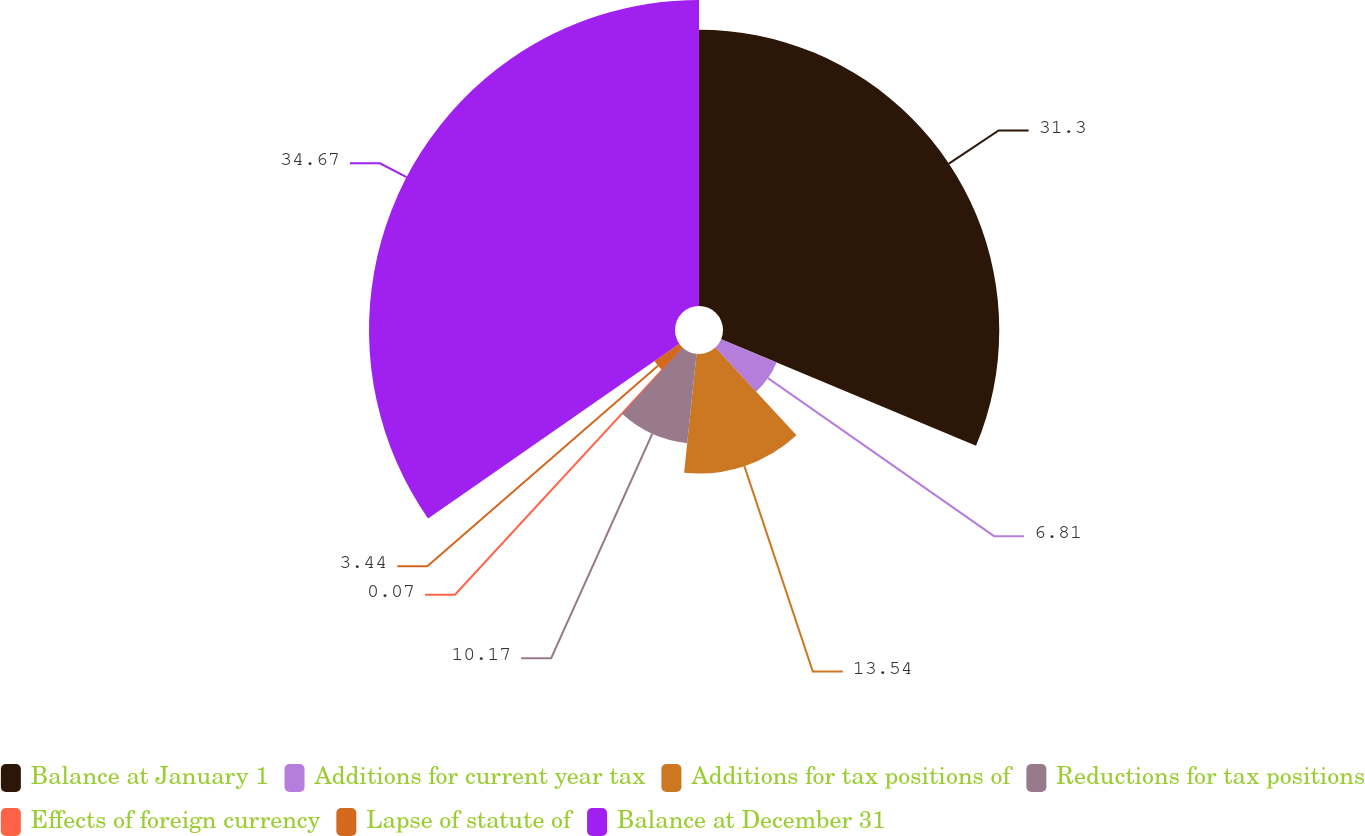Convert chart to OTSL. <chart><loc_0><loc_0><loc_500><loc_500><pie_chart><fcel>Balance at January 1<fcel>Additions for current year tax<fcel>Additions for tax positions of<fcel>Reductions for tax positions<fcel>Effects of foreign currency<fcel>Lapse of statute of<fcel>Balance at December 31<nl><fcel>31.3%<fcel>6.81%<fcel>13.54%<fcel>10.17%<fcel>0.07%<fcel>3.44%<fcel>34.67%<nl></chart> 